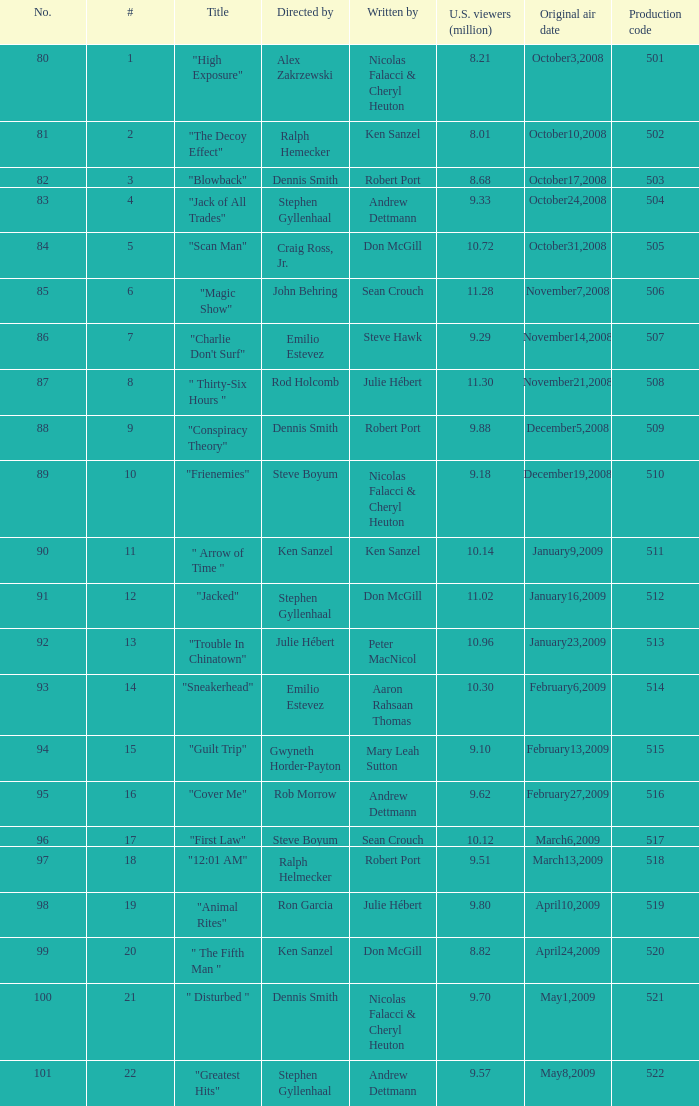Help me parse the entirety of this table. {'header': ['No.', '#', 'Title', 'Directed by', 'Written by', 'U.S. viewers (million)', 'Original air date', 'Production code'], 'rows': [['80', '1', '"High Exposure"', 'Alex Zakrzewski', 'Nicolas Falacci & Cheryl Heuton', '8.21', 'October3,2008', '501'], ['81', '2', '"The Decoy Effect"', 'Ralph Hemecker', 'Ken Sanzel', '8.01', 'October10,2008', '502'], ['82', '3', '"Blowback"', 'Dennis Smith', 'Robert Port', '8.68', 'October17,2008', '503'], ['83', '4', '"Jack of All Trades"', 'Stephen Gyllenhaal', 'Andrew Dettmann', '9.33', 'October24,2008', '504'], ['84', '5', '"Scan Man"', 'Craig Ross, Jr.', 'Don McGill', '10.72', 'October31,2008', '505'], ['85', '6', '"Magic Show"', 'John Behring', 'Sean Crouch', '11.28', 'November7,2008', '506'], ['86', '7', '"Charlie Don\'t Surf"', 'Emilio Estevez', 'Steve Hawk', '9.29', 'November14,2008', '507'], ['87', '8', '" Thirty-Six Hours "', 'Rod Holcomb', 'Julie Hébert', '11.30', 'November21,2008', '508'], ['88', '9', '"Conspiracy Theory"', 'Dennis Smith', 'Robert Port', '9.88', 'December5,2008', '509'], ['89', '10', '"Frienemies"', 'Steve Boyum', 'Nicolas Falacci & Cheryl Heuton', '9.18', 'December19,2008', '510'], ['90', '11', '" Arrow of Time "', 'Ken Sanzel', 'Ken Sanzel', '10.14', 'January9,2009', '511'], ['91', '12', '"Jacked"', 'Stephen Gyllenhaal', 'Don McGill', '11.02', 'January16,2009', '512'], ['92', '13', '"Trouble In Chinatown"', 'Julie Hébert', 'Peter MacNicol', '10.96', 'January23,2009', '513'], ['93', '14', '"Sneakerhead"', 'Emilio Estevez', 'Aaron Rahsaan Thomas', '10.30', 'February6,2009', '514'], ['94', '15', '"Guilt Trip"', 'Gwyneth Horder-Payton', 'Mary Leah Sutton', '9.10', 'February13,2009', '515'], ['95', '16', '"Cover Me"', 'Rob Morrow', 'Andrew Dettmann', '9.62', 'February27,2009', '516'], ['96', '17', '"First Law"', 'Steve Boyum', 'Sean Crouch', '10.12', 'March6,2009', '517'], ['97', '18', '"12:01 AM"', 'Ralph Helmecker', 'Robert Port', '9.51', 'March13,2009', '518'], ['98', '19', '"Animal Rites"', 'Ron Garcia', 'Julie Hébert', '9.80', 'April10,2009', '519'], ['99', '20', '" The Fifth Man "', 'Ken Sanzel', 'Don McGill', '8.82', 'April24,2009', '520'], ['100', '21', '" Disturbed "', 'Dennis Smith', 'Nicolas Falacci & Cheryl Heuton', '9.70', 'May1,2009', '521'], ['101', '22', '"Greatest Hits"', 'Stephen Gyllenhaal', 'Andrew Dettmann', '9.57', 'May8,2009', '522']]} What episode number was directed by Craig Ross, Jr. 5.0. 